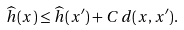Convert formula to latex. <formula><loc_0><loc_0><loc_500><loc_500>\widehat { h } ( x ) \leq \widehat { h } ( x ^ { \prime } ) + C \, d ( x , x ^ { \prime } ) .</formula> 